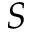Convert formula to latex. <formula><loc_0><loc_0><loc_500><loc_500>S</formula> 